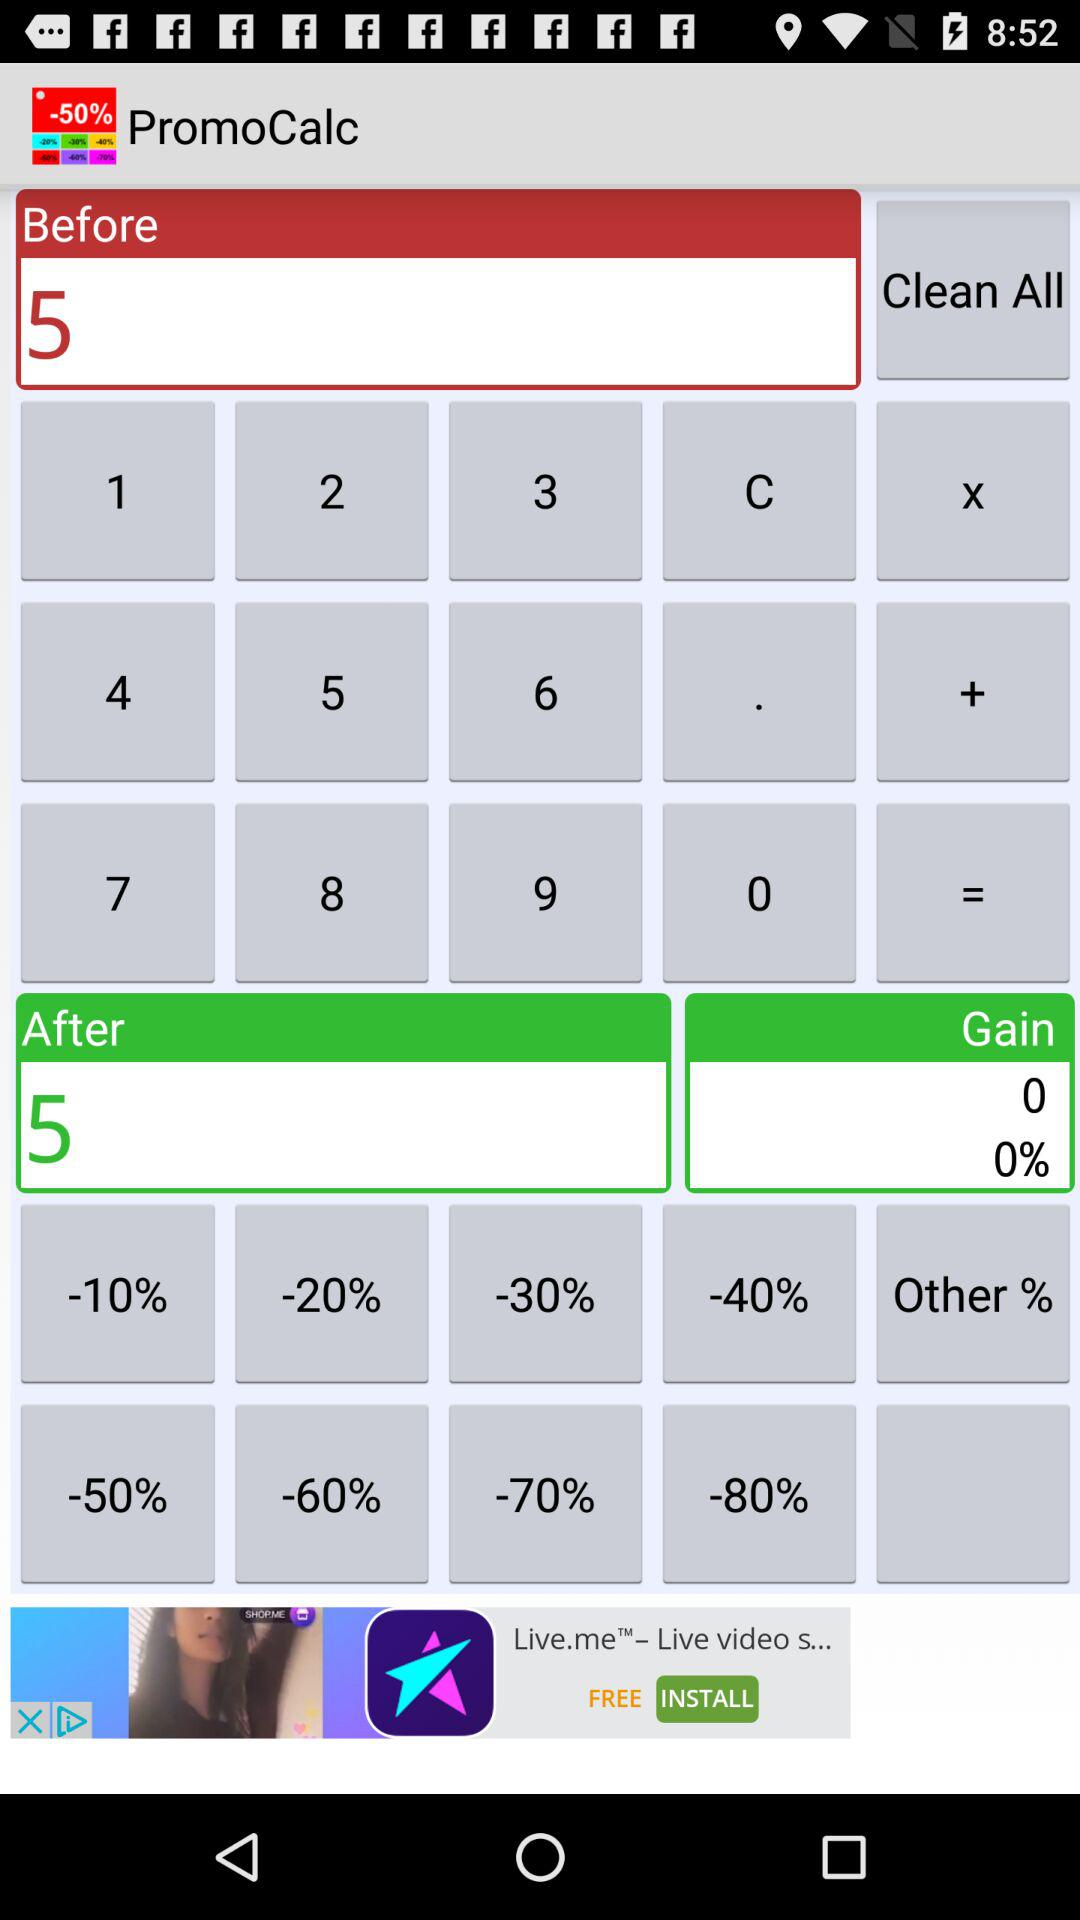What is the number in "Before"? The number in "Before" is 5. 